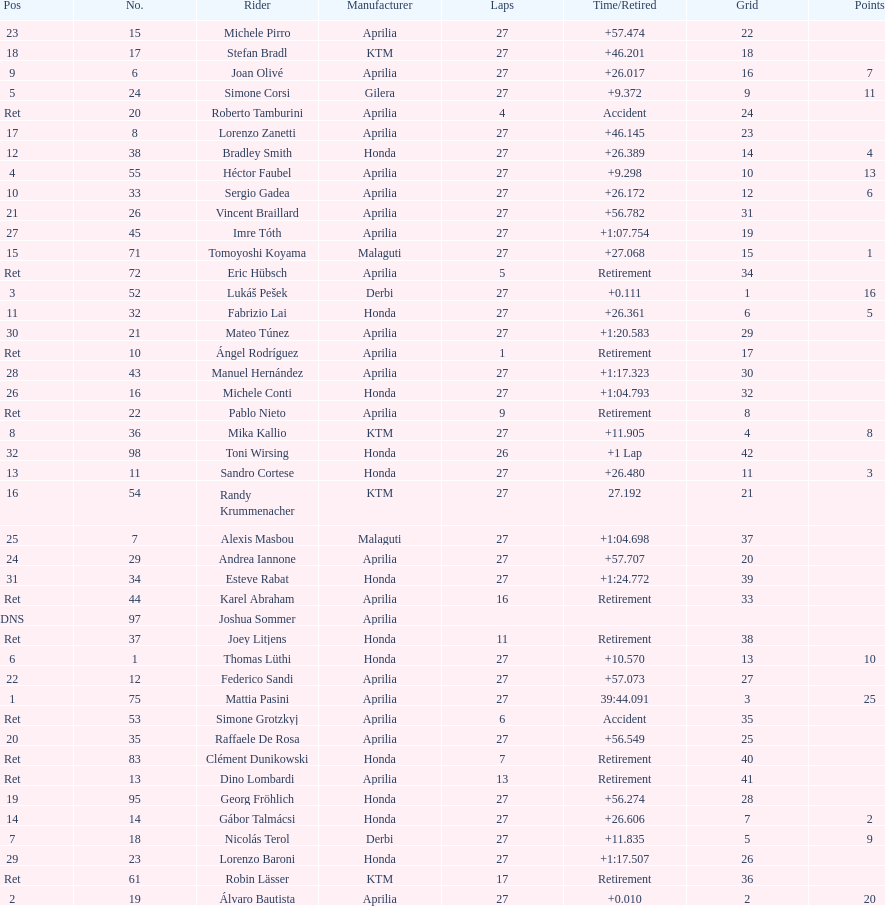What was the total number of positions in the 125cc classification? 43. 